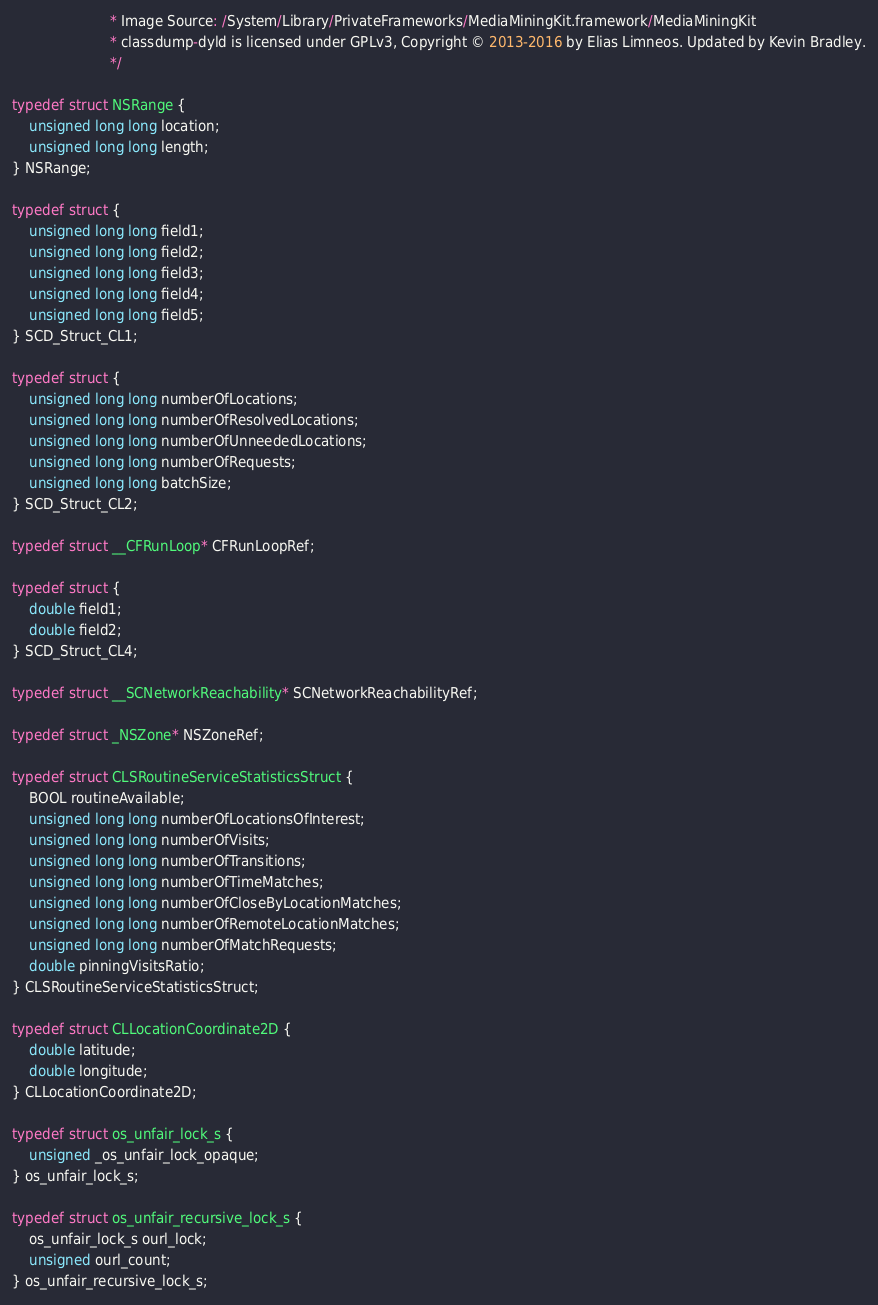<code> <loc_0><loc_0><loc_500><loc_500><_C_>                       * Image Source: /System/Library/PrivateFrameworks/MediaMiningKit.framework/MediaMiningKit
                       * classdump-dyld is licensed under GPLv3, Copyright © 2013-2016 by Elias Limneos. Updated by Kevin Bradley.
                       */

typedef struct NSRange {
	unsigned long long location;
	unsigned long long length;
} NSRange;

typedef struct {
	unsigned long long field1;
	unsigned long long field2;
	unsigned long long field3;
	unsigned long long field4;
	unsigned long long field5;
} SCD_Struct_CL1;

typedef struct {
	unsigned long long numberOfLocations;
	unsigned long long numberOfResolvedLocations;
	unsigned long long numberOfUnneededLocations;
	unsigned long long numberOfRequests;
	unsigned long long batchSize;
} SCD_Struct_CL2;

typedef struct __CFRunLoop* CFRunLoopRef;

typedef struct {
	double field1;
	double field2;
} SCD_Struct_CL4;

typedef struct __SCNetworkReachability* SCNetworkReachabilityRef;

typedef struct _NSZone* NSZoneRef;

typedef struct CLSRoutineServiceStatisticsStruct {
	BOOL routineAvailable;
	unsigned long long numberOfLocationsOfInterest;
	unsigned long long numberOfVisits;
	unsigned long long numberOfTransitions;
	unsigned long long numberOfTimeMatches;
	unsigned long long numberOfCloseByLocationMatches;
	unsigned long long numberOfRemoteLocationMatches;
	unsigned long long numberOfMatchRequests;
	double pinningVisitsRatio;
} CLSRoutineServiceStatisticsStruct;

typedef struct CLLocationCoordinate2D {
	double latitude;
	double longitude;
} CLLocationCoordinate2D;

typedef struct os_unfair_lock_s {
	unsigned _os_unfair_lock_opaque;
} os_unfair_lock_s;

typedef struct os_unfair_recursive_lock_s {
	os_unfair_lock_s ourl_lock;
	unsigned ourl_count;
} os_unfair_recursive_lock_s;

</code> 